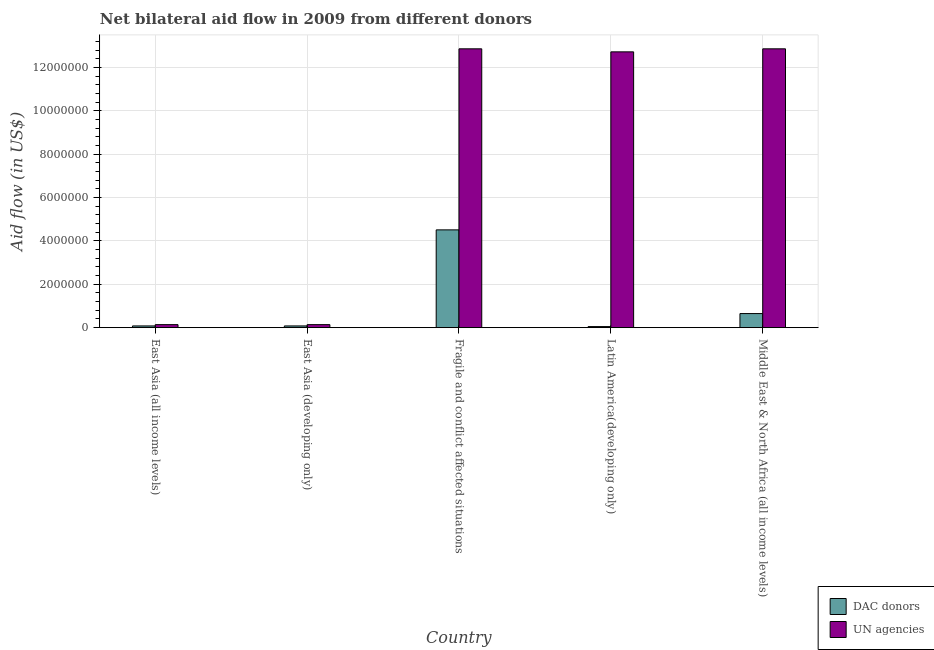Are the number of bars per tick equal to the number of legend labels?
Your answer should be very brief. Yes. Are the number of bars on each tick of the X-axis equal?
Offer a very short reply. Yes. How many bars are there on the 3rd tick from the left?
Offer a very short reply. 2. What is the label of the 4th group of bars from the left?
Your answer should be compact. Latin America(developing only). What is the aid flow from dac donors in East Asia (developing only)?
Your answer should be compact. 8.00e+04. Across all countries, what is the maximum aid flow from un agencies?
Ensure brevity in your answer.  1.29e+07. Across all countries, what is the minimum aid flow from un agencies?
Your response must be concise. 1.40e+05. In which country was the aid flow from dac donors maximum?
Keep it short and to the point. Fragile and conflict affected situations. In which country was the aid flow from dac donors minimum?
Your answer should be very brief. Latin America(developing only). What is the total aid flow from un agencies in the graph?
Ensure brevity in your answer.  3.87e+07. What is the difference between the aid flow from dac donors in East Asia (all income levels) and that in Latin America(developing only)?
Provide a succinct answer. 3.00e+04. What is the difference between the aid flow from un agencies in Latin America(developing only) and the aid flow from dac donors in East Asia (all income levels)?
Provide a short and direct response. 1.26e+07. What is the average aid flow from dac donors per country?
Offer a very short reply. 1.07e+06. What is the difference between the aid flow from dac donors and aid flow from un agencies in Latin America(developing only)?
Your answer should be very brief. -1.27e+07. In how many countries, is the aid flow from un agencies greater than 12000000 US$?
Provide a succinct answer. 3. What is the ratio of the aid flow from un agencies in East Asia (developing only) to that in Fragile and conflict affected situations?
Make the answer very short. 0.01. Is the aid flow from dac donors in East Asia (all income levels) less than that in Middle East & North Africa (all income levels)?
Your answer should be very brief. Yes. What is the difference between the highest and the second highest aid flow from dac donors?
Make the answer very short. 3.86e+06. What is the difference between the highest and the lowest aid flow from dac donors?
Your answer should be very brief. 4.46e+06. What does the 1st bar from the left in East Asia (developing only) represents?
Provide a short and direct response. DAC donors. What does the 2nd bar from the right in Fragile and conflict affected situations represents?
Provide a succinct answer. DAC donors. Are all the bars in the graph horizontal?
Make the answer very short. No. Are the values on the major ticks of Y-axis written in scientific E-notation?
Give a very brief answer. No. Does the graph contain any zero values?
Keep it short and to the point. No. Where does the legend appear in the graph?
Offer a terse response. Bottom right. How many legend labels are there?
Provide a short and direct response. 2. What is the title of the graph?
Your response must be concise. Net bilateral aid flow in 2009 from different donors. What is the label or title of the Y-axis?
Your answer should be compact. Aid flow (in US$). What is the Aid flow (in US$) of UN agencies in East Asia (all income levels)?
Ensure brevity in your answer.  1.40e+05. What is the Aid flow (in US$) in DAC donors in Fragile and conflict affected situations?
Keep it short and to the point. 4.51e+06. What is the Aid flow (in US$) in UN agencies in Fragile and conflict affected situations?
Make the answer very short. 1.29e+07. What is the Aid flow (in US$) in DAC donors in Latin America(developing only)?
Provide a short and direct response. 5.00e+04. What is the Aid flow (in US$) of UN agencies in Latin America(developing only)?
Your response must be concise. 1.27e+07. What is the Aid flow (in US$) of DAC donors in Middle East & North Africa (all income levels)?
Offer a very short reply. 6.50e+05. What is the Aid flow (in US$) in UN agencies in Middle East & North Africa (all income levels)?
Your response must be concise. 1.29e+07. Across all countries, what is the maximum Aid flow (in US$) in DAC donors?
Make the answer very short. 4.51e+06. Across all countries, what is the maximum Aid flow (in US$) of UN agencies?
Make the answer very short. 1.29e+07. Across all countries, what is the minimum Aid flow (in US$) in DAC donors?
Provide a succinct answer. 5.00e+04. What is the total Aid flow (in US$) in DAC donors in the graph?
Provide a short and direct response. 5.37e+06. What is the total Aid flow (in US$) of UN agencies in the graph?
Keep it short and to the point. 3.87e+07. What is the difference between the Aid flow (in US$) in DAC donors in East Asia (all income levels) and that in Fragile and conflict affected situations?
Your answer should be very brief. -4.43e+06. What is the difference between the Aid flow (in US$) of UN agencies in East Asia (all income levels) and that in Fragile and conflict affected situations?
Your response must be concise. -1.27e+07. What is the difference between the Aid flow (in US$) of DAC donors in East Asia (all income levels) and that in Latin America(developing only)?
Provide a succinct answer. 3.00e+04. What is the difference between the Aid flow (in US$) of UN agencies in East Asia (all income levels) and that in Latin America(developing only)?
Offer a terse response. -1.26e+07. What is the difference between the Aid flow (in US$) in DAC donors in East Asia (all income levels) and that in Middle East & North Africa (all income levels)?
Give a very brief answer. -5.70e+05. What is the difference between the Aid flow (in US$) in UN agencies in East Asia (all income levels) and that in Middle East & North Africa (all income levels)?
Give a very brief answer. -1.27e+07. What is the difference between the Aid flow (in US$) in DAC donors in East Asia (developing only) and that in Fragile and conflict affected situations?
Ensure brevity in your answer.  -4.43e+06. What is the difference between the Aid flow (in US$) in UN agencies in East Asia (developing only) and that in Fragile and conflict affected situations?
Offer a terse response. -1.27e+07. What is the difference between the Aid flow (in US$) in DAC donors in East Asia (developing only) and that in Latin America(developing only)?
Your response must be concise. 3.00e+04. What is the difference between the Aid flow (in US$) in UN agencies in East Asia (developing only) and that in Latin America(developing only)?
Offer a very short reply. -1.26e+07. What is the difference between the Aid flow (in US$) in DAC donors in East Asia (developing only) and that in Middle East & North Africa (all income levels)?
Give a very brief answer. -5.70e+05. What is the difference between the Aid flow (in US$) of UN agencies in East Asia (developing only) and that in Middle East & North Africa (all income levels)?
Keep it short and to the point. -1.27e+07. What is the difference between the Aid flow (in US$) in DAC donors in Fragile and conflict affected situations and that in Latin America(developing only)?
Your response must be concise. 4.46e+06. What is the difference between the Aid flow (in US$) of UN agencies in Fragile and conflict affected situations and that in Latin America(developing only)?
Your answer should be compact. 1.40e+05. What is the difference between the Aid flow (in US$) of DAC donors in Fragile and conflict affected situations and that in Middle East & North Africa (all income levels)?
Your response must be concise. 3.86e+06. What is the difference between the Aid flow (in US$) in UN agencies in Fragile and conflict affected situations and that in Middle East & North Africa (all income levels)?
Offer a terse response. 0. What is the difference between the Aid flow (in US$) of DAC donors in Latin America(developing only) and that in Middle East & North Africa (all income levels)?
Keep it short and to the point. -6.00e+05. What is the difference between the Aid flow (in US$) in DAC donors in East Asia (all income levels) and the Aid flow (in US$) in UN agencies in East Asia (developing only)?
Your response must be concise. -6.00e+04. What is the difference between the Aid flow (in US$) of DAC donors in East Asia (all income levels) and the Aid flow (in US$) of UN agencies in Fragile and conflict affected situations?
Keep it short and to the point. -1.28e+07. What is the difference between the Aid flow (in US$) in DAC donors in East Asia (all income levels) and the Aid flow (in US$) in UN agencies in Latin America(developing only)?
Your response must be concise. -1.26e+07. What is the difference between the Aid flow (in US$) of DAC donors in East Asia (all income levels) and the Aid flow (in US$) of UN agencies in Middle East & North Africa (all income levels)?
Offer a terse response. -1.28e+07. What is the difference between the Aid flow (in US$) in DAC donors in East Asia (developing only) and the Aid flow (in US$) in UN agencies in Fragile and conflict affected situations?
Your answer should be compact. -1.28e+07. What is the difference between the Aid flow (in US$) in DAC donors in East Asia (developing only) and the Aid flow (in US$) in UN agencies in Latin America(developing only)?
Your answer should be compact. -1.26e+07. What is the difference between the Aid flow (in US$) in DAC donors in East Asia (developing only) and the Aid flow (in US$) in UN agencies in Middle East & North Africa (all income levels)?
Give a very brief answer. -1.28e+07. What is the difference between the Aid flow (in US$) of DAC donors in Fragile and conflict affected situations and the Aid flow (in US$) of UN agencies in Latin America(developing only)?
Make the answer very short. -8.21e+06. What is the difference between the Aid flow (in US$) in DAC donors in Fragile and conflict affected situations and the Aid flow (in US$) in UN agencies in Middle East & North Africa (all income levels)?
Offer a terse response. -8.35e+06. What is the difference between the Aid flow (in US$) of DAC donors in Latin America(developing only) and the Aid flow (in US$) of UN agencies in Middle East & North Africa (all income levels)?
Your answer should be compact. -1.28e+07. What is the average Aid flow (in US$) of DAC donors per country?
Your answer should be compact. 1.07e+06. What is the average Aid flow (in US$) of UN agencies per country?
Give a very brief answer. 7.74e+06. What is the difference between the Aid flow (in US$) in DAC donors and Aid flow (in US$) in UN agencies in East Asia (developing only)?
Provide a succinct answer. -6.00e+04. What is the difference between the Aid flow (in US$) in DAC donors and Aid flow (in US$) in UN agencies in Fragile and conflict affected situations?
Offer a terse response. -8.35e+06. What is the difference between the Aid flow (in US$) in DAC donors and Aid flow (in US$) in UN agencies in Latin America(developing only)?
Give a very brief answer. -1.27e+07. What is the difference between the Aid flow (in US$) in DAC donors and Aid flow (in US$) in UN agencies in Middle East & North Africa (all income levels)?
Your answer should be very brief. -1.22e+07. What is the ratio of the Aid flow (in US$) in DAC donors in East Asia (all income levels) to that in East Asia (developing only)?
Your response must be concise. 1. What is the ratio of the Aid flow (in US$) in DAC donors in East Asia (all income levels) to that in Fragile and conflict affected situations?
Provide a succinct answer. 0.02. What is the ratio of the Aid flow (in US$) in UN agencies in East Asia (all income levels) to that in Fragile and conflict affected situations?
Provide a succinct answer. 0.01. What is the ratio of the Aid flow (in US$) of UN agencies in East Asia (all income levels) to that in Latin America(developing only)?
Ensure brevity in your answer.  0.01. What is the ratio of the Aid flow (in US$) of DAC donors in East Asia (all income levels) to that in Middle East & North Africa (all income levels)?
Offer a terse response. 0.12. What is the ratio of the Aid flow (in US$) in UN agencies in East Asia (all income levels) to that in Middle East & North Africa (all income levels)?
Your answer should be very brief. 0.01. What is the ratio of the Aid flow (in US$) of DAC donors in East Asia (developing only) to that in Fragile and conflict affected situations?
Keep it short and to the point. 0.02. What is the ratio of the Aid flow (in US$) in UN agencies in East Asia (developing only) to that in Fragile and conflict affected situations?
Make the answer very short. 0.01. What is the ratio of the Aid flow (in US$) in UN agencies in East Asia (developing only) to that in Latin America(developing only)?
Your answer should be very brief. 0.01. What is the ratio of the Aid flow (in US$) of DAC donors in East Asia (developing only) to that in Middle East & North Africa (all income levels)?
Give a very brief answer. 0.12. What is the ratio of the Aid flow (in US$) of UN agencies in East Asia (developing only) to that in Middle East & North Africa (all income levels)?
Offer a terse response. 0.01. What is the ratio of the Aid flow (in US$) in DAC donors in Fragile and conflict affected situations to that in Latin America(developing only)?
Offer a terse response. 90.2. What is the ratio of the Aid flow (in US$) of UN agencies in Fragile and conflict affected situations to that in Latin America(developing only)?
Your answer should be compact. 1.01. What is the ratio of the Aid flow (in US$) in DAC donors in Fragile and conflict affected situations to that in Middle East & North Africa (all income levels)?
Your answer should be compact. 6.94. What is the ratio of the Aid flow (in US$) of UN agencies in Fragile and conflict affected situations to that in Middle East & North Africa (all income levels)?
Your answer should be very brief. 1. What is the ratio of the Aid flow (in US$) in DAC donors in Latin America(developing only) to that in Middle East & North Africa (all income levels)?
Ensure brevity in your answer.  0.08. What is the ratio of the Aid flow (in US$) in UN agencies in Latin America(developing only) to that in Middle East & North Africa (all income levels)?
Give a very brief answer. 0.99. What is the difference between the highest and the second highest Aid flow (in US$) in DAC donors?
Your response must be concise. 3.86e+06. What is the difference between the highest and the lowest Aid flow (in US$) in DAC donors?
Ensure brevity in your answer.  4.46e+06. What is the difference between the highest and the lowest Aid flow (in US$) of UN agencies?
Your answer should be very brief. 1.27e+07. 